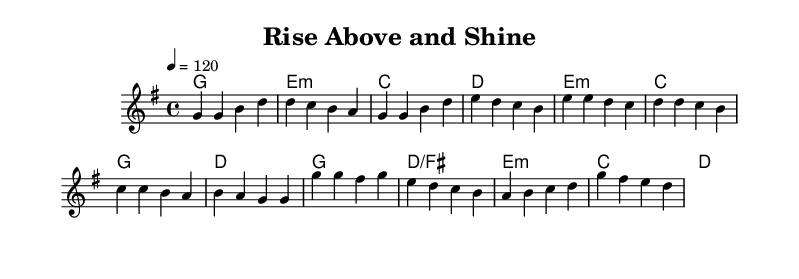What is the key signature of this music? The key signature is G major, which has one sharp (F#).
Answer: G major What is the time signature of this music? The time signature is 4/4, indicating four beats per measure.
Answer: 4/4 What is the tempo marking for this piece? The tempo marking is 120 beats per minute, indicating a moderately fast pace.
Answer: 120 How many measures are in the verse section? The verse section consists of 4 measures, as counted from the melody part.
Answer: 4 What is the harmonic function of the chord in the first measure? The first measure uses the G major chord, which serves as the tonic.
Answer: Tonic On which chord does the chorus start? The chorus starts on the G major chord, which is the tonic in this context.
Answer: G What is the pattern of note repetition in the chorus? The chorus features the repetition of the note G, indicating a strong, uplifting theme.
Answer: G 